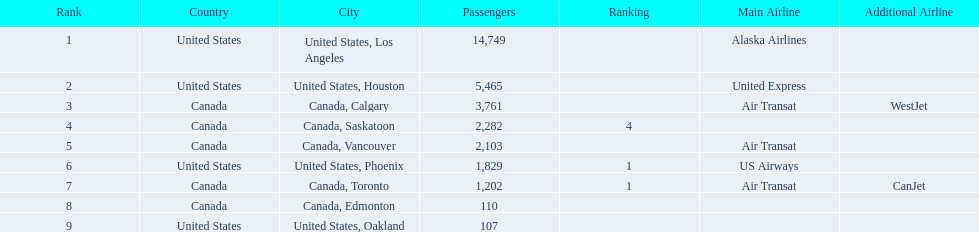What are the cities that are associated with the playa de oro international airport? United States, Los Angeles, United States, Houston, Canada, Calgary, Canada, Saskatoon, Canada, Vancouver, United States, Phoenix, Canada, Toronto, Canada, Edmonton, United States, Oakland. What is uniteed states, los angeles passenger count? 14,749. What other cities passenger count would lead to 19,000 roughly when combined with previous los angeles? Canada, Calgary. 